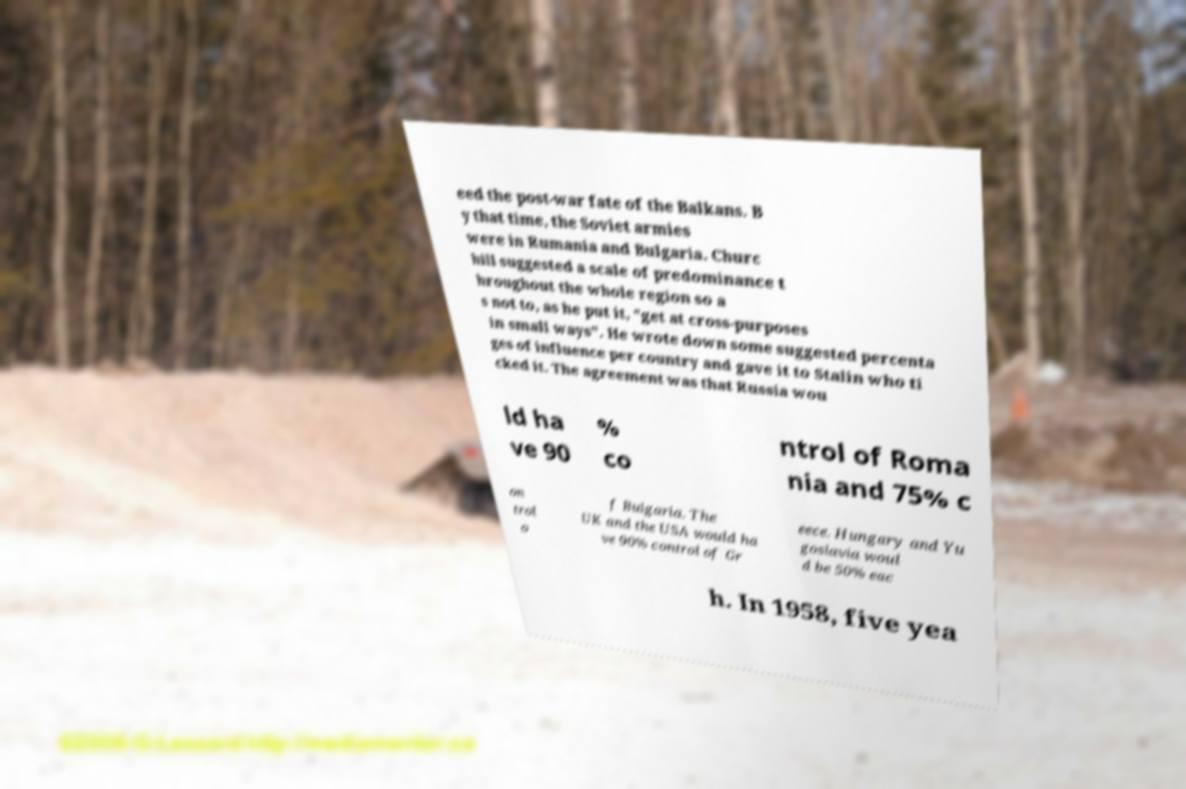Could you extract and type out the text from this image? eed the post-war fate of the Balkans. B y that time, the Soviet armies were in Rumania and Bulgaria. Churc hill suggested a scale of predominance t hroughout the whole region so a s not to, as he put it, "get at cross-purposes in small ways". He wrote down some suggested percenta ges of influence per country and gave it to Stalin who ti cked it. The agreement was that Russia wou ld ha ve 90 % co ntrol of Roma nia and 75% c on trol o f Bulgaria. The UK and the USA would ha ve 90% control of Gr eece. Hungary and Yu goslavia woul d be 50% eac h. In 1958, five yea 